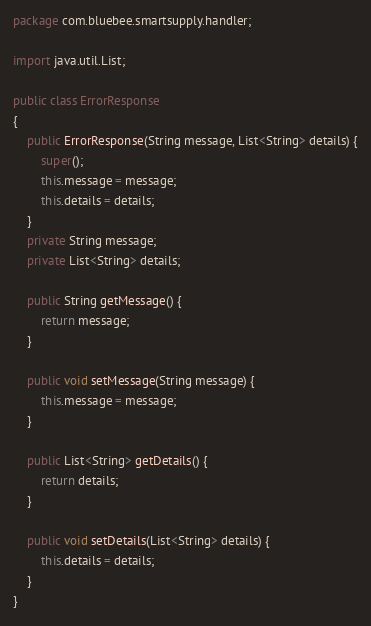Convert code to text. <code><loc_0><loc_0><loc_500><loc_500><_Java_>package com.bluebee.smartsupply.handler;

import java.util.List;

public class ErrorResponse
{
	public ErrorResponse(String message, List<String> details) {
		super();
		this.message = message;
		this.details = details;
	}
	private String message;
	private List<String> details;

	public String getMessage() {
		return message;
	}

	public void setMessage(String message) {
		this.message = message;
	}

	public List<String> getDetails() {
		return details;
	}

	public void setDetails(List<String> details) {
		this.details = details;
	}
}</code> 